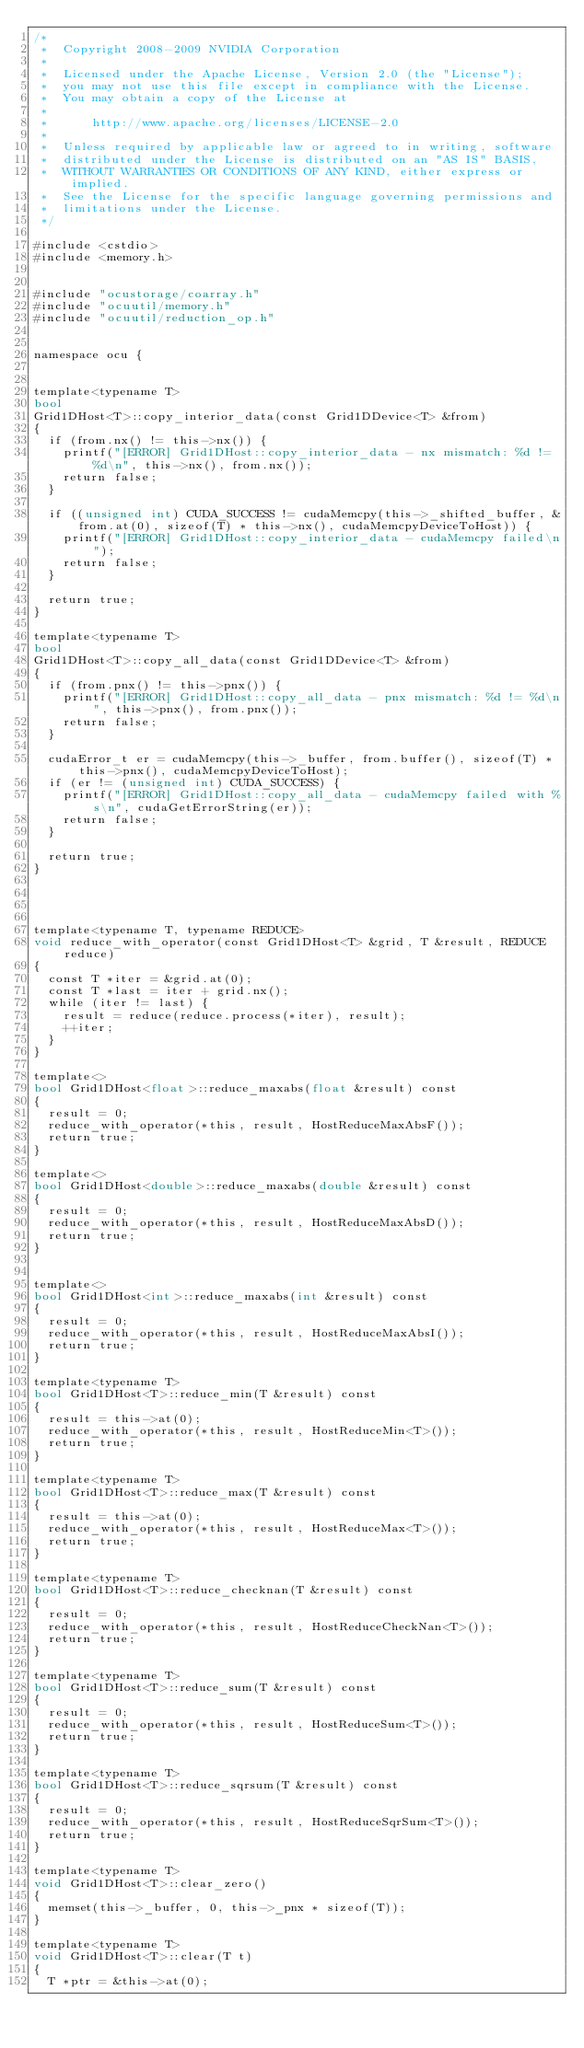Convert code to text. <code><loc_0><loc_0><loc_500><loc_500><_Cuda_>/*
 *  Copyright 2008-2009 NVIDIA Corporation
 *
 *  Licensed under the Apache License, Version 2.0 (the "License");
 *  you may not use this file except in compliance with the License.
 *  You may obtain a copy of the License at
 *
 *      http://www.apache.org/licenses/LICENSE-2.0
 *
 *  Unless required by applicable law or agreed to in writing, software
 *  distributed under the License is distributed on an "AS IS" BASIS,
 *  WITHOUT WARRANTIES OR CONDITIONS OF ANY KIND, either express or implied.
 *  See the License for the specific language governing permissions and
 *  limitations under the License.
 */

#include <cstdio>
#include <memory.h>


#include "ocustorage/coarray.h"
#include "ocuutil/memory.h"
#include "ocuutil/reduction_op.h"


namespace ocu {


template<typename T>
bool 
Grid1DHost<T>::copy_interior_data(const Grid1DDevice<T> &from)
{
  if (from.nx() != this->nx()) {
    printf("[ERROR] Grid1DHost::copy_interior_data - nx mismatch: %d != %d\n", this->nx(), from.nx());
    return false;
  }

  if ((unsigned int) CUDA_SUCCESS != cudaMemcpy(this->_shifted_buffer, &from.at(0), sizeof(T) * this->nx(), cudaMemcpyDeviceToHost)) {
    printf("[ERROR] Grid1DHost::copy_interior_data - cudaMemcpy failed\n");
    return false;
  }
  
  return true;
}

template<typename T>
bool 
Grid1DHost<T>::copy_all_data(const Grid1DDevice<T> &from)
{
  if (from.pnx() != this->pnx()) {
    printf("[ERROR] Grid1DHost::copy_all_data - pnx mismatch: %d != %d\n", this->pnx(), from.pnx());
    return false;
  }

  cudaError_t er = cudaMemcpy(this->_buffer, from.buffer(), sizeof(T) * this->pnx(), cudaMemcpyDeviceToHost);
  if (er != (unsigned int) CUDA_SUCCESS) {
    printf("[ERROR] Grid1DHost::copy_all_data - cudaMemcpy failed with %s\n", cudaGetErrorString(er));
    return false;
  }
  
  return true;
}




template<typename T, typename REDUCE>
void reduce_with_operator(const Grid1DHost<T> &grid, T &result, REDUCE reduce)
{
  const T *iter = &grid.at(0);
  const T *last = iter + grid.nx();
  while (iter != last) {
    result = reduce(reduce.process(*iter), result);
    ++iter;
  }
}

template<>
bool Grid1DHost<float>::reduce_maxabs(float &result) const
{
  result = 0;
  reduce_with_operator(*this, result, HostReduceMaxAbsF());
  return true;
}

template<>
bool Grid1DHost<double>::reduce_maxabs(double &result) const
{
  result = 0;
  reduce_with_operator(*this, result, HostReduceMaxAbsD());
  return true;
}


template<>
bool Grid1DHost<int>::reduce_maxabs(int &result) const
{
  result = 0;
  reduce_with_operator(*this, result, HostReduceMaxAbsI());
  return true;
}

template<typename T>
bool Grid1DHost<T>::reduce_min(T &result) const
{
  result = this->at(0);
  reduce_with_operator(*this, result, HostReduceMin<T>());
  return true;
}

template<typename T>
bool Grid1DHost<T>::reduce_max(T &result) const
{
  result = this->at(0);
  reduce_with_operator(*this, result, HostReduceMax<T>());
  return true;
}

template<typename T>
bool Grid1DHost<T>::reduce_checknan(T &result) const
{
  result = 0;
  reduce_with_operator(*this, result, HostReduceCheckNan<T>());
  return true;
}

template<typename T>
bool Grid1DHost<T>::reduce_sum(T &result) const
{
  result = 0;
  reduce_with_operator(*this, result, HostReduceSum<T>());
  return true;
}

template<typename T>
bool Grid1DHost<T>::reduce_sqrsum(T &result) const
{
  result = 0;
  reduce_with_operator(*this, result, HostReduceSqrSum<T>());
  return true;
}

template<typename T>
void Grid1DHost<T>::clear_zero()
{
  memset(this->_buffer, 0, this->_pnx * sizeof(T));
}

template<typename T>
void Grid1DHost<T>::clear(T t)
{
  T *ptr = &this->at(0);</code> 